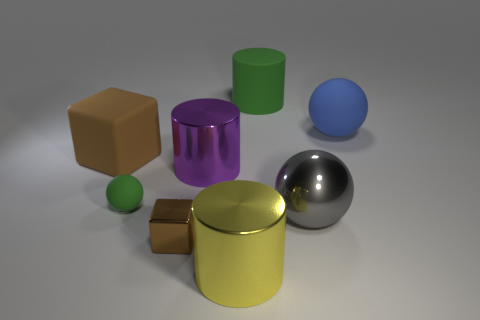Subtract all large blue balls. How many balls are left? 2 Add 2 big red rubber cylinders. How many objects exist? 10 Subtract all red spheres. Subtract all purple blocks. How many spheres are left? 3 Subtract all cubes. How many objects are left? 6 Add 6 large cyan balls. How many large cyan balls exist? 6 Subtract 0 cyan cylinders. How many objects are left? 8 Subtract all small purple rubber spheres. Subtract all big blue rubber spheres. How many objects are left? 7 Add 6 large green matte objects. How many large green matte objects are left? 7 